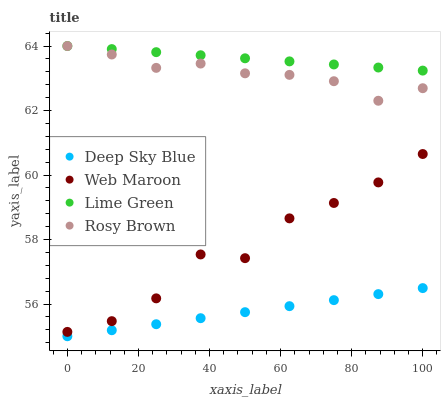Does Deep Sky Blue have the minimum area under the curve?
Answer yes or no. Yes. Does Lime Green have the maximum area under the curve?
Answer yes or no. Yes. Does Rosy Brown have the minimum area under the curve?
Answer yes or no. No. Does Rosy Brown have the maximum area under the curve?
Answer yes or no. No. Is Lime Green the smoothest?
Answer yes or no. Yes. Is Web Maroon the roughest?
Answer yes or no. Yes. Is Rosy Brown the smoothest?
Answer yes or no. No. Is Rosy Brown the roughest?
Answer yes or no. No. Does Deep Sky Blue have the lowest value?
Answer yes or no. Yes. Does Rosy Brown have the lowest value?
Answer yes or no. No. Does Rosy Brown have the highest value?
Answer yes or no. Yes. Does Web Maroon have the highest value?
Answer yes or no. No. Is Web Maroon less than Lime Green?
Answer yes or no. Yes. Is Lime Green greater than Deep Sky Blue?
Answer yes or no. Yes. Does Lime Green intersect Rosy Brown?
Answer yes or no. Yes. Is Lime Green less than Rosy Brown?
Answer yes or no. No. Is Lime Green greater than Rosy Brown?
Answer yes or no. No. Does Web Maroon intersect Lime Green?
Answer yes or no. No. 